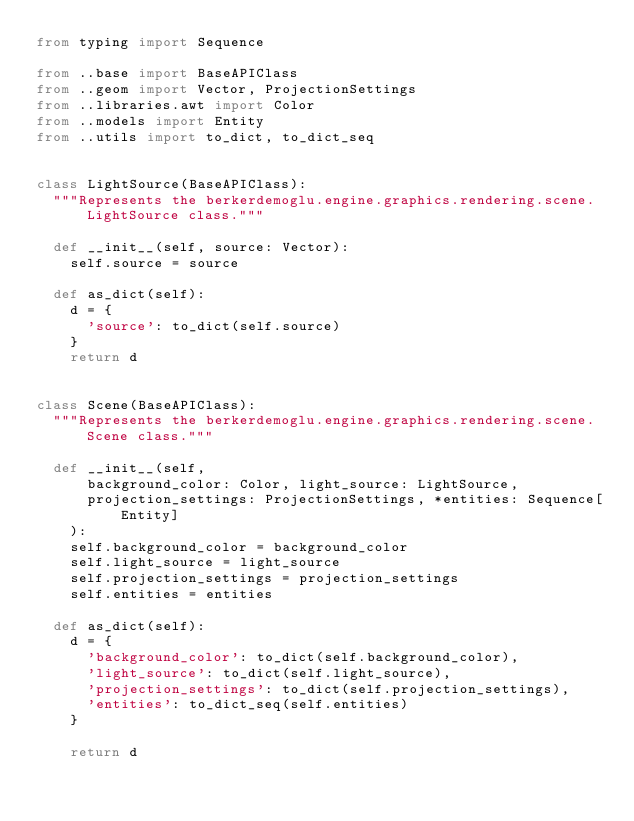<code> <loc_0><loc_0><loc_500><loc_500><_Python_>from typing import Sequence

from ..base import BaseAPIClass
from ..geom import Vector, ProjectionSettings
from ..libraries.awt import Color
from ..models import Entity
from ..utils import to_dict, to_dict_seq


class LightSource(BaseAPIClass):
	"""Represents the berkerdemoglu.engine.graphics.rendering.scene.LightSource class."""

	def __init__(self, source: Vector):
		self.source = source

	def as_dict(self):
		d = {
			'source': to_dict(self.source)
		}
		return d


class Scene(BaseAPIClass):
	"""Represents the berkerdemoglu.engine.graphics.rendering.scene.Scene class."""

	def __init__(self, 
			background_color: Color, light_source: LightSource,
			projection_settings: ProjectionSettings, *entities: Sequence[Entity]
		):
		self.background_color = background_color
		self.light_source = light_source
		self.projection_settings = projection_settings
		self.entities = entities

	def as_dict(self):
		d = {
			'background_color': to_dict(self.background_color),
			'light_source': to_dict(self.light_source),
			'projection_settings': to_dict(self.projection_settings),
			'entities': to_dict_seq(self.entities)
		}
		
		return d
</code> 